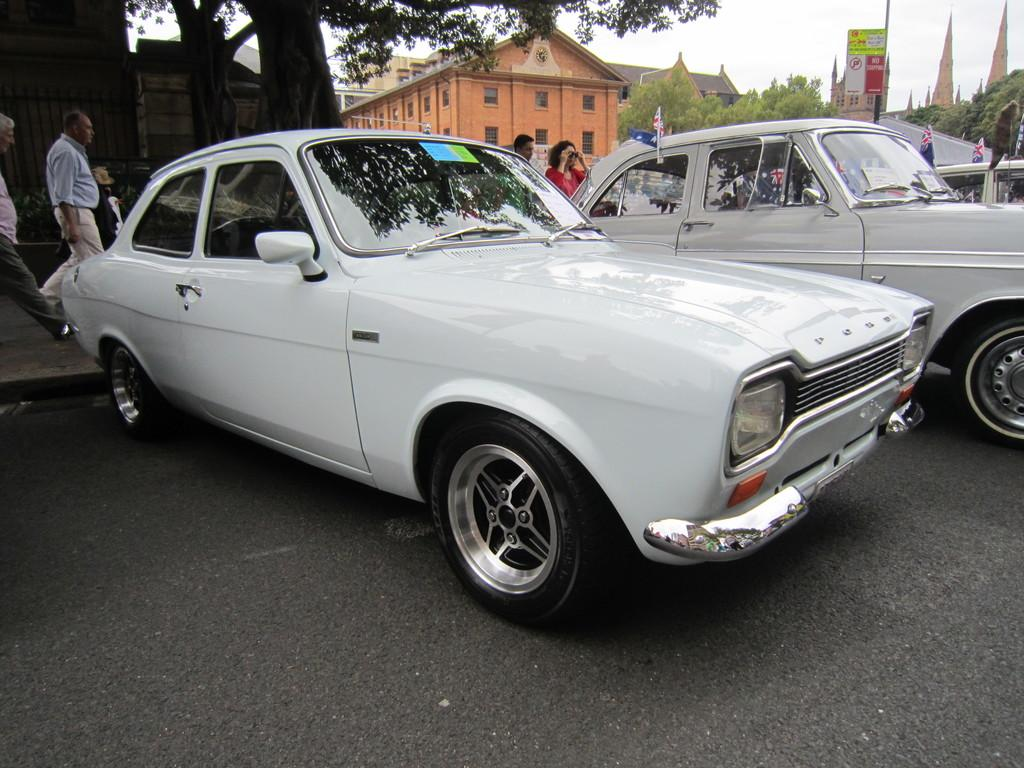What can be seen on the road in the image? There are cars on the road in the image. How many people are present in the image? There are four persons in the image. What objects are present in the image that represent a country or organization? There are flags in the image. What type of advertisement is visible in the image? There is a hoarding in the image. What type of vegetation is present in the image? There are trees in the image. What type of structures are present in the image? There are buildings in the image. What part of the natural environment is visible in the background of the image? The sky is visible in the background of the image. What type of thought can be seen in the image? There are no thoughts visible in the image; it is a photograph of a scene. What type of beast can be seen in the image? There are no beasts visible in the image. 